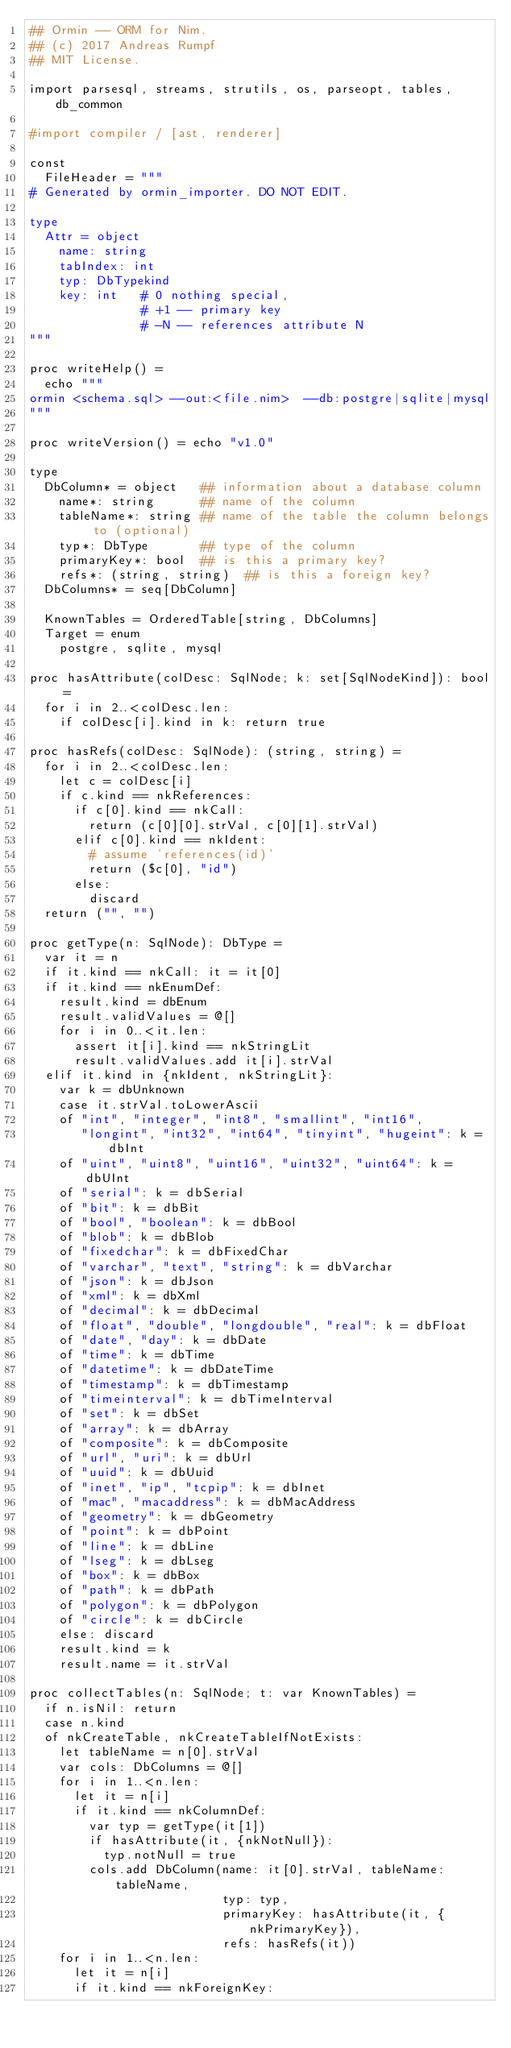Convert code to text. <code><loc_0><loc_0><loc_500><loc_500><_Nim_>## Ormin -- ORM for Nim.
## (c) 2017 Andreas Rumpf
## MIT License.

import parsesql, streams, strutils, os, parseopt, tables, db_common

#import compiler / [ast, renderer]

const
  FileHeader = """
# Generated by ormin_importer. DO NOT EDIT.

type
  Attr = object
    name: string
    tabIndex: int
    typ: DbTypekind
    key: int   # 0 nothing special,
               # +1 -- primary key
               # -N -- references attribute N
"""

proc writeHelp() =
  echo """
ormin <schema.sql> --out:<file.nim>  --db:postgre|sqlite|mysql
"""

proc writeVersion() = echo "v1.0"

type
  DbColumn* = object   ## information about a database column
    name*: string      ## name of the column
    tableName*: string ## name of the table the column belongs to (optional)
    typ*: DbType       ## type of the column
    primaryKey*: bool  ## is this a primary key?
    refs*: (string, string)  ## is this a foreign key?
  DbColumns* = seq[DbColumn]

  KnownTables = OrderedTable[string, DbColumns]
  Target = enum
    postgre, sqlite, mysql

proc hasAttribute(colDesc: SqlNode; k: set[SqlNodeKind]): bool =
  for i in 2..<colDesc.len:
    if colDesc[i].kind in k: return true

proc hasRefs(colDesc: SqlNode): (string, string) =
  for i in 2..<colDesc.len:
    let c = colDesc[i]
    if c.kind == nkReferences:
      if c[0].kind == nkCall:
        return (c[0][0].strVal, c[0][1].strVal)
      elif c[0].kind == nkIdent:
        # assume 'references(id)'
        return ($c[0], "id")
      else:
        discard
  return ("", "")

proc getType(n: SqlNode): DbType =
  var it = n
  if it.kind == nkCall: it = it[0]
  if it.kind == nkEnumDef:
    result.kind = dbEnum
    result.validValues = @[]
    for i in 0..<it.len:
      assert it[i].kind == nkStringLit
      result.validValues.add it[i].strVal
  elif it.kind in {nkIdent, nkStringLit}:
    var k = dbUnknown
    case it.strVal.toLowerAscii
    of "int", "integer", "int8", "smallint", "int16",
       "longint", "int32", "int64", "tinyint", "hugeint": k = dbInt
    of "uint", "uint8", "uint16", "uint32", "uint64": k = dbUInt
    of "serial": k = dbSerial
    of "bit": k = dbBit
    of "bool", "boolean": k = dbBool
    of "blob": k = dbBlob
    of "fixedchar": k = dbFixedChar
    of "varchar", "text", "string": k = dbVarchar
    of "json": k = dbJson
    of "xml": k = dbXml
    of "decimal": k = dbDecimal
    of "float", "double", "longdouble", "real": k = dbFloat
    of "date", "day": k = dbDate
    of "time": k = dbTime
    of "datetime": k = dbDateTime
    of "timestamp": k = dbTimestamp
    of "timeinterval": k = dbTimeInterval
    of "set": k = dbSet
    of "array": k = dbArray
    of "composite": k = dbComposite
    of "url", "uri": k = dbUrl
    of "uuid": k = dbUuid
    of "inet", "ip", "tcpip": k = dbInet
    of "mac", "macaddress": k = dbMacAddress
    of "geometry": k = dbGeometry
    of "point": k = dbPoint
    of "line": k = dbLine
    of "lseg": k = dbLseg
    of "box": k = dbBox
    of "path": k = dbPath
    of "polygon": k = dbPolygon
    of "circle": k = dbCircle
    else: discard
    result.kind = k
    result.name = it.strVal

proc collectTables(n: SqlNode; t: var KnownTables) =
  if n.isNil: return
  case n.kind
  of nkCreateTable, nkCreateTableIfNotExists:
    let tableName = n[0].strVal
    var cols: DbColumns = @[]
    for i in 1..<n.len:
      let it = n[i]
      if it.kind == nkColumnDef:
        var typ = getType(it[1])
        if hasAttribute(it, {nkNotNull}):
          typ.notNull = true
        cols.add DbColumn(name: it[0].strVal, tableName: tableName,
                          typ: typ,
                          primaryKey: hasAttribute(it, {nkPrimaryKey}),
                          refs: hasRefs(it))
    for i in 1..<n.len:
      let it = n[i]
      if it.kind == nkForeignKey:</code> 